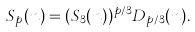Convert formula to latex. <formula><loc_0><loc_0><loc_500><loc_500>S _ { p } ( n ) = ( S _ { 3 } ( n ) ) ^ { p / 3 } D _ { p / 3 } ( n ) .</formula> 